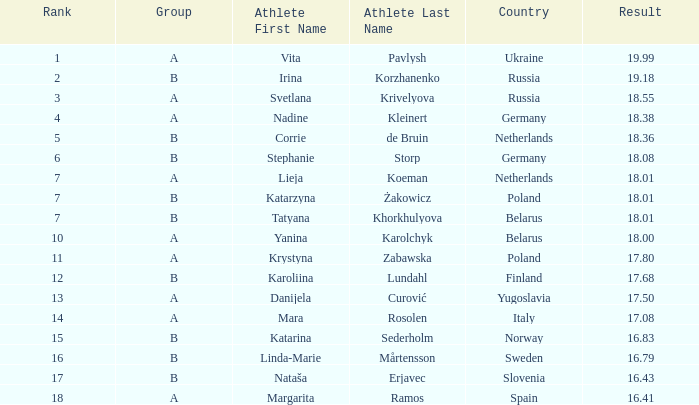What is the average rank for Group A athlete Yanina Karolchyk, and a result higher than 18? None. 